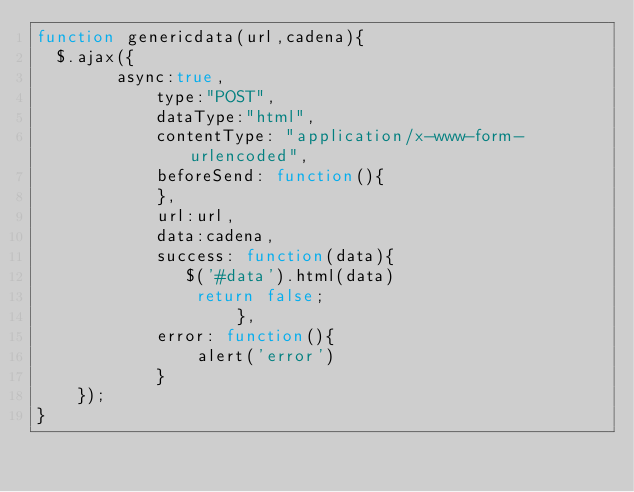<code> <loc_0><loc_0><loc_500><loc_500><_JavaScript_>function genericdata(url,cadena){ 
  $.ajax({
		async:true,  
			type:"POST",  
			dataType:"html",    
			contentType: "application/x-www-form-urlencoded",
			beforeSend: function(){ 
            },
			url:url,  
			data:cadena, 
			success: function(data){  
               $('#data').html(data)
                return false;
					},
			error: function(){
                alert('error')
			}
	});
}</code> 